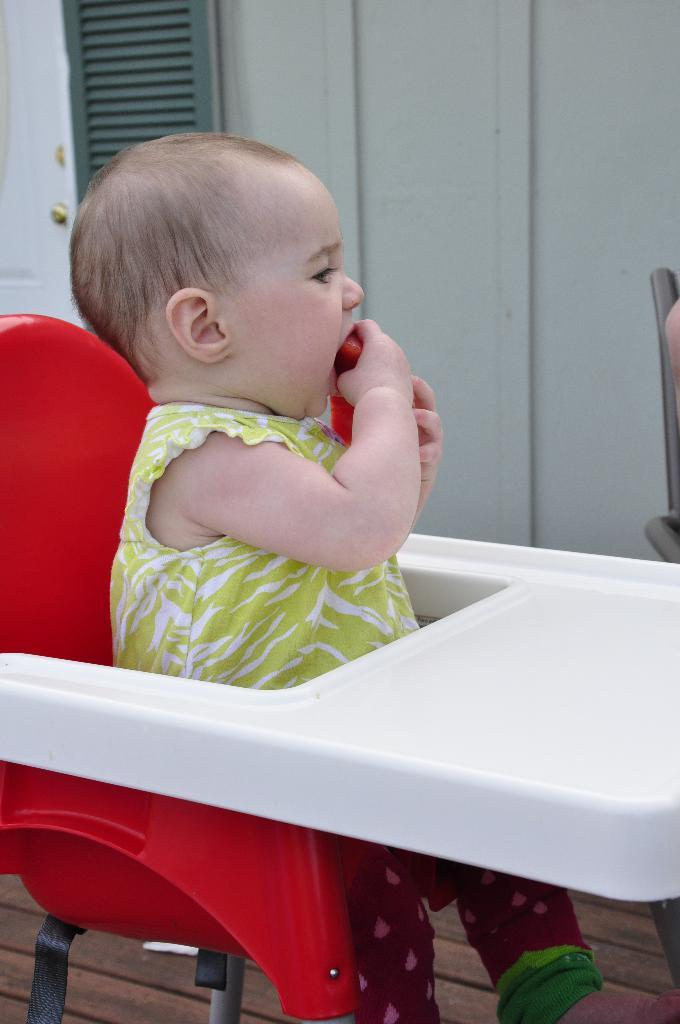What is the main subject of the image? There is a baby in the image. What is the baby wearing? The baby is wearing a white and green dress. Where is the baby sitting? The baby is sitting on a chair. What is present in the image besides the baby? There is a table in the image. What is the baby doing in the image? The baby is eating something. What can be seen in the background of the image? There is a wall in the background of the image. What type of flower is sitting on the lamp in the image? There is no lamp or flower present in the image. What toys is the baby playing with in the image? The baby is not playing with any toys in the image; they are eating something. 